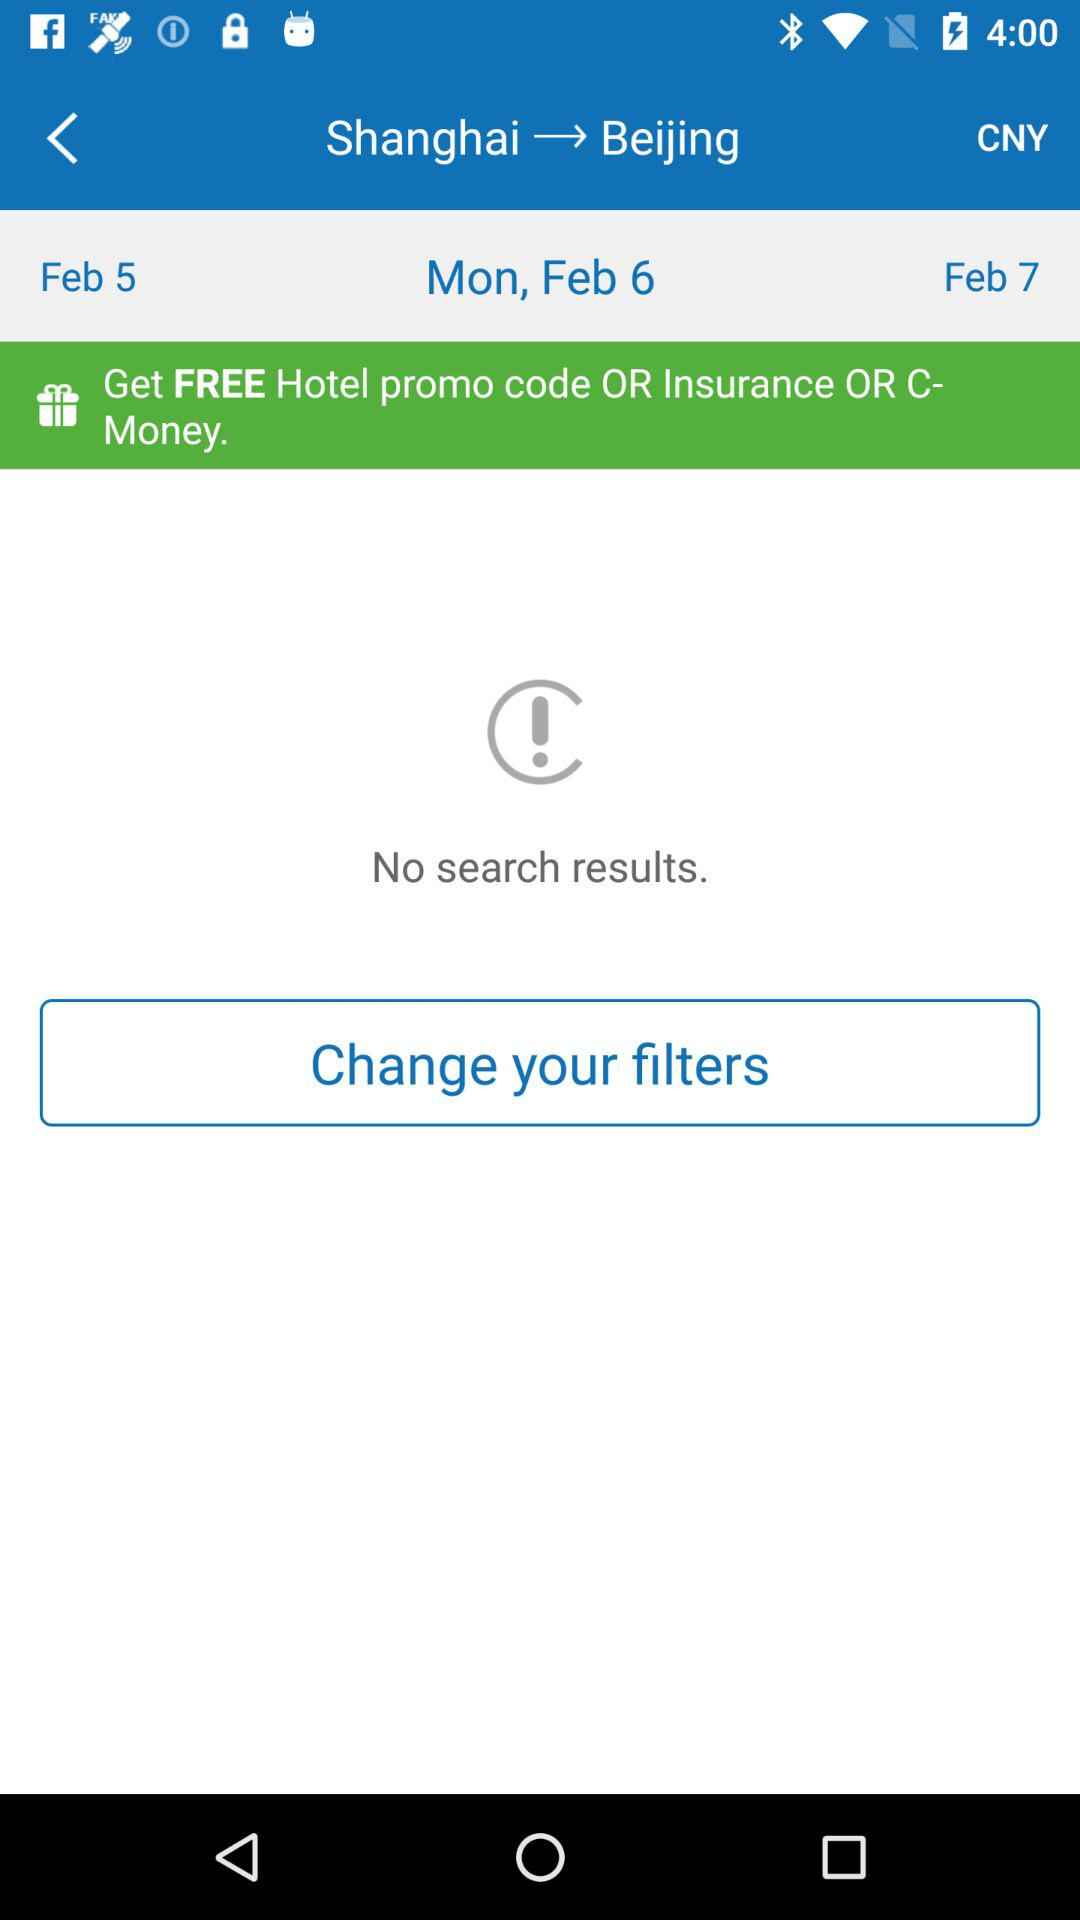What is the destination? The destination is "Beijing". 